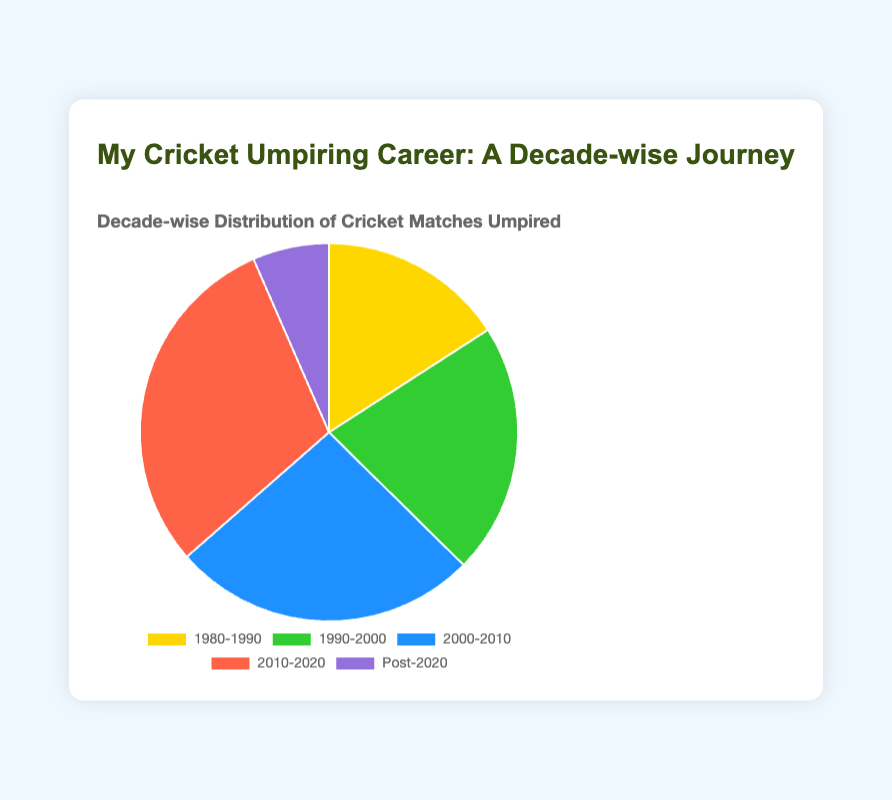What decade has the highest number of cricket matches umpired? The decade with the highest number of cricket matches umpired is 2010-2020, as indicated by the largest portion of the pie chart.
Answer: 2010-2020 Which decade has fewer matches umpired, 1980-1990 or Post-2020? By comparing the sizes of the slices representing these decades, it is clear the Post-2020 has fewer matches umpired than 1980-1990.
Answer: Post-2020 What is the sum of matches umpired in the decades 1990-2000 and 2000-2010? The number of matches umpired in 1990-2000 is 115, and in 2000-2010 is 140. Summing these gives 115 + 140 = 255 matches.
Answer: 255 What percentage of the total matches were umpired in the 2010-2020 decade? Total matches umpired across all decades add up to 85 + 115 + 140 + 160 + 35 = 535. The matches in the 2010-2020 decade are 160. The percentage is (160/535) * 100 ≈ 29.91%.
Answer: approximately 29.91% Compare the number of matches umpired in the 1990-2000 decade to the Post-2020 decade. By looking at the figures from the chart, the number of matches in 1990-2000 is 115, whereas Post-2020 is 35. Hence, 1990-2000 has more matches.
Answer: 1990-2000 Which color represents the 2000-2010 decade, and how many matches were umpired during that time? The color representing the 2000-2010 decade is blue, and 140 matches were umpired during this period, as indicated by the chart.
Answer: blue, 140 How does the number of matches in the 2010-2020 decade compare to the total number of matches in the 1980-1990 and Post-2020 decades combined? The number of matches in the 2010-2020 decade is 160. The combined total for 1980-1990 and Post-2020 is 85 + 35 = 120. The 2010-2020 decade has more matches.
Answer: 2010-2020 has more What is the average number of matches umpired per decade? Sum the total matches (85+115+140+160+35=535) and divide by the number of decades (5), which results in 535/5 = 107 matches per decade.
Answer: 107 